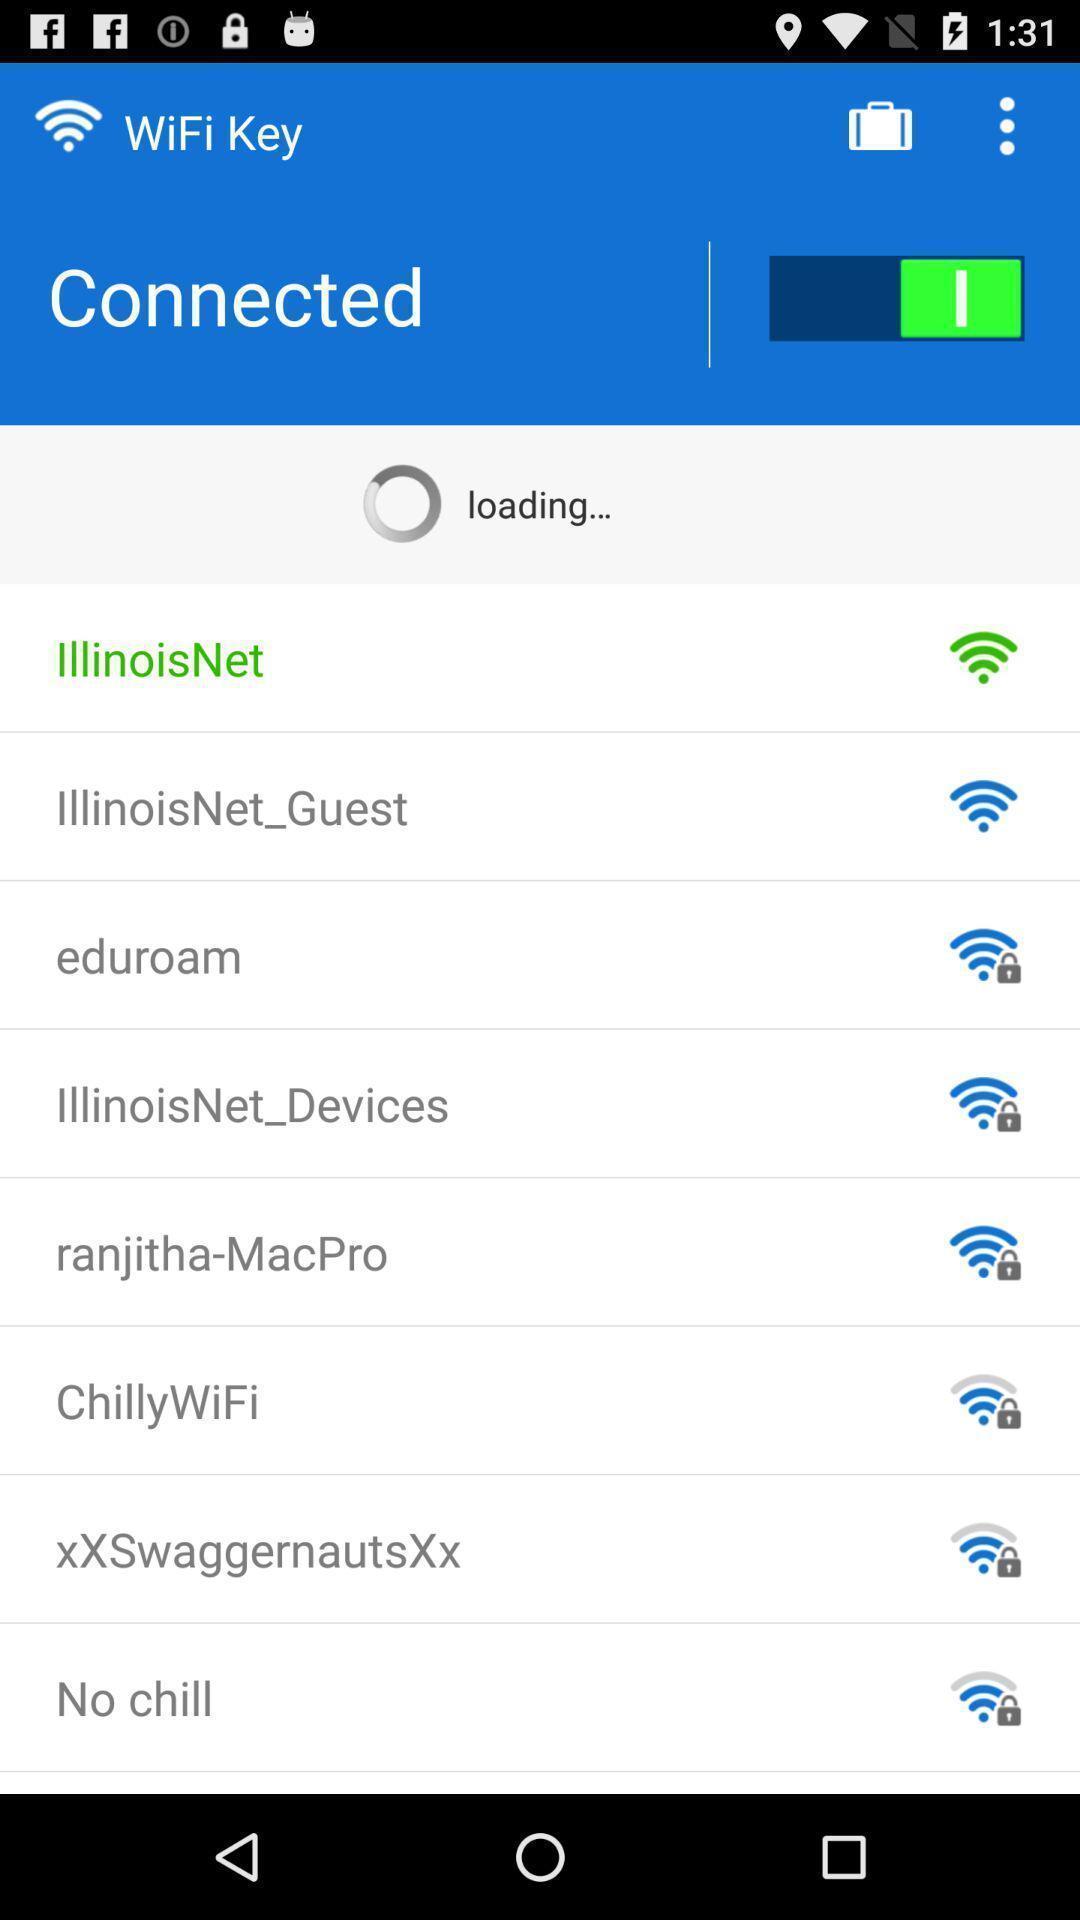Provide a description of this screenshot. Screen showing all the available networks. 